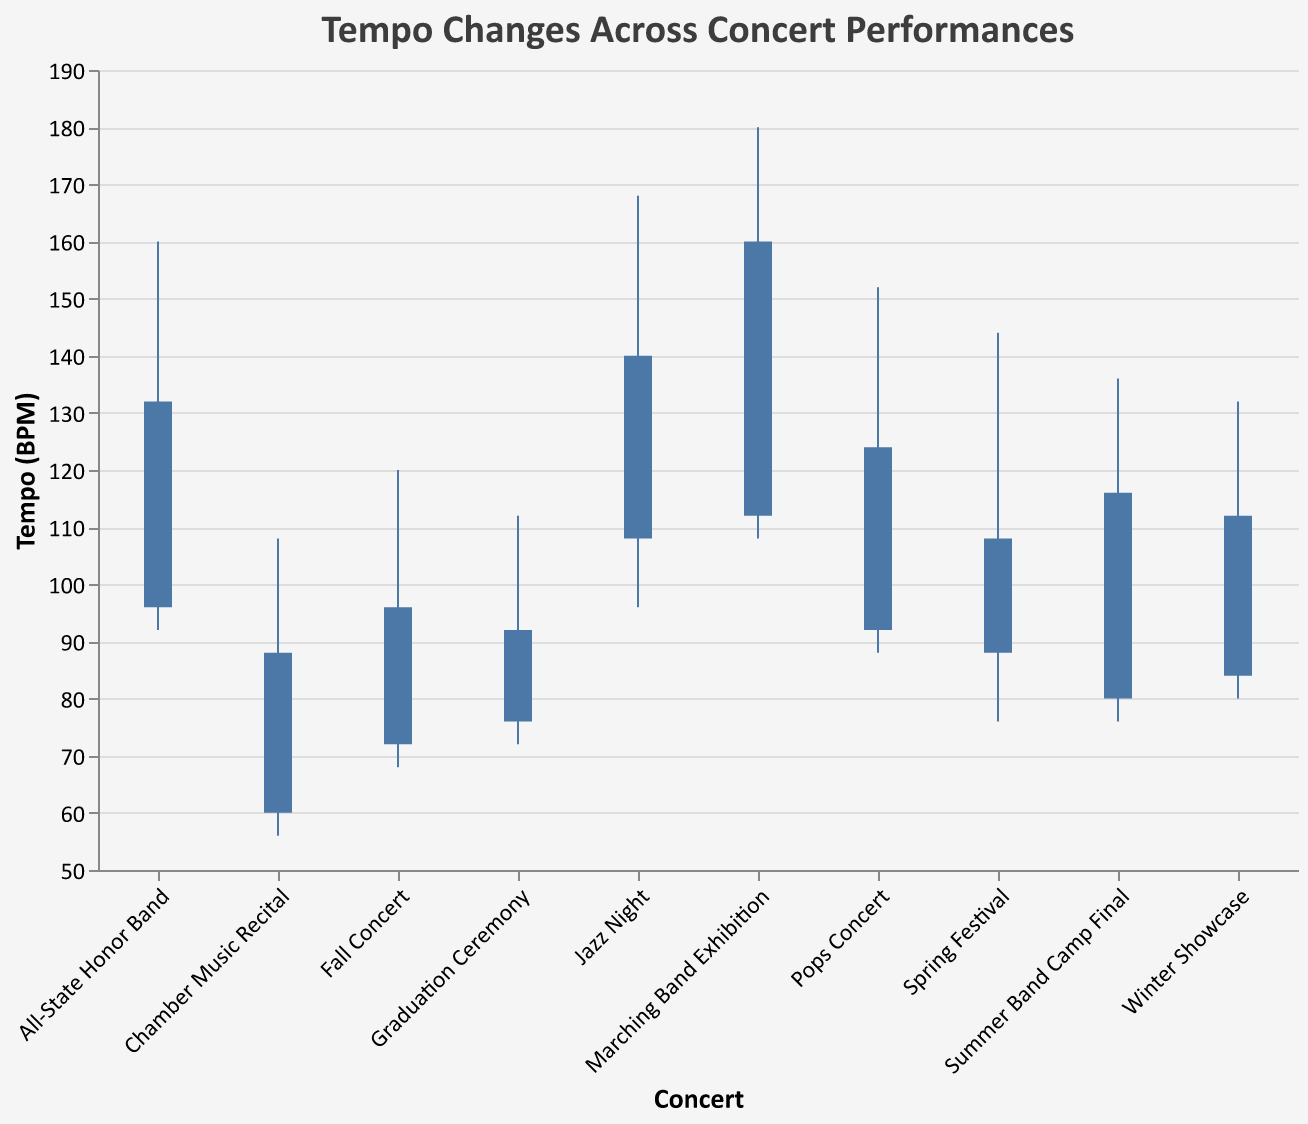What's the title of the figure? The title of the figure is shown at the top of the chart in a larger font size than the other text. It reads "Tempo Changes Across Concert Performances".
Answer: Tempo Changes Across Concert Performances What is the highest tempo observed across all the concerts? The highest tempo is observed by looking at the tallest vertical line on the chart. The "Marching Band Exhibition" concert has the highest tempo, reaching 180 BPM.
Answer: 180 BPM Which concert has the lowest opening tempo? By observing the starting points of the bars, "Chamber Music Recital" has the lowest opening tempo of 60 BPM.
Answer: Chamber Music Recital How does the closing tempo of "Jazz Night" compare to the opening tempo of "Winter Showcase"? The closing tempo of "Jazz Night" is 140 BPM, and the opening tempo of "Winter Showcase" is 84 BPM. Since 140 is greater than 84, the closing tempo of "Jazz Night" is higher.
Answer: Jazz Night's closing tempo is higher Which concerts have a closing tempo higher than their opening tempo? By examining the bars, the concerts "Winter Showcase", "Pops Concert", "Jazz Night", "Summer Band Camp Final", "All-State Honor Band", and "Marching Band Exhibition" have a closing tempo higher than their opening tempo, as indicated by the upward direction of the bars.
Answer: Winter Showcase, Pops Concert, Jazz Night, Summer Band Camp Final, All-State Honor Band, Marching Band Exhibition What is the average high tempo of the "Spring Festival" and "Graduation Ceremony"? The high tempo of "Spring Festival" is 144 BPM, and the high tempo of "Graduation Ceremony" is 112 BPM. The average is calculated as (144 + 112) / 2 = 128 BPM.
Answer: 128 BPM Which concert shows the most significant range between the high tempo and the low tempo during the performance? The concert with the most significant range can be found by examining the length of the vertical lines. "Marching Band Exhibition" has the largest range from 108 BPM to 180 BPM, which is a range of 72 BPM.
Answer: Marching Band Exhibition How does the tempo range of "Fall Concert" compare to the tempo range of "Chamber Music Recital"? The tempo range of "Fall Concert" is from 68 BPM to 120 BPM, which is 120 - 68 = 52 BPM. The range for "Chamber Music Recital" is from 56 BPM to 108 BPM, which is 108 - 56 = 52 BPM. Both have the same range.
Answer: Same range What is the cumulative high tempo of all concerts combined? The cumulative high tempo is found by summing the high tempo of all concerts: 120 + 132 + 144 + 152 + 168 + 112 + 136 + 160 + 180 + 108 = 1,412 BPM.
Answer: 1,412 BPM Which concerts have a low tempo of 76 BPM or below? Concerts with a low tempo of 76 BPM or below are "Spring Festival", "Graduation Ceremony", "Chamber Music Recital", and "Summer Band Camp Final". This is identified by examining the minimum points of the vertical lines.
Answer: Spring Festival, Graduation Ceremony, Chamber Music Recital, Summer Band Camp Final 